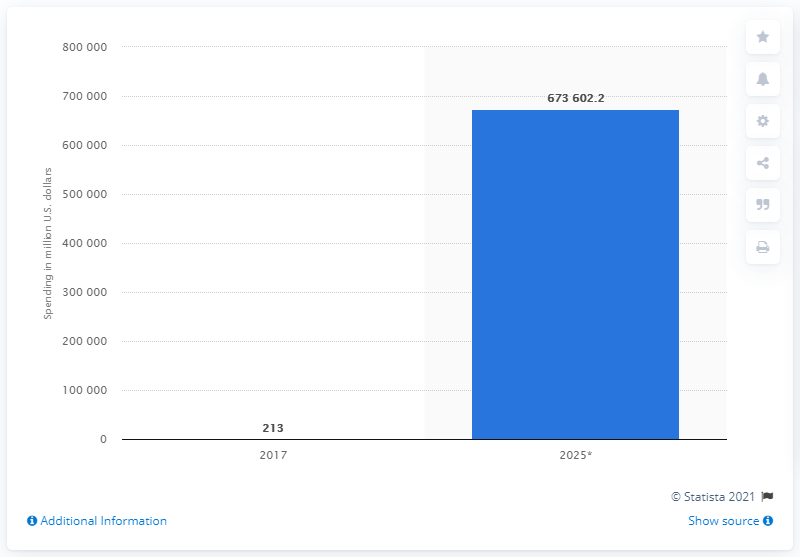Draw attention to some important aspects in this diagram. The global automotive AR and VR market is forecast to reach a value of 67,360,220.2 by 2025. 